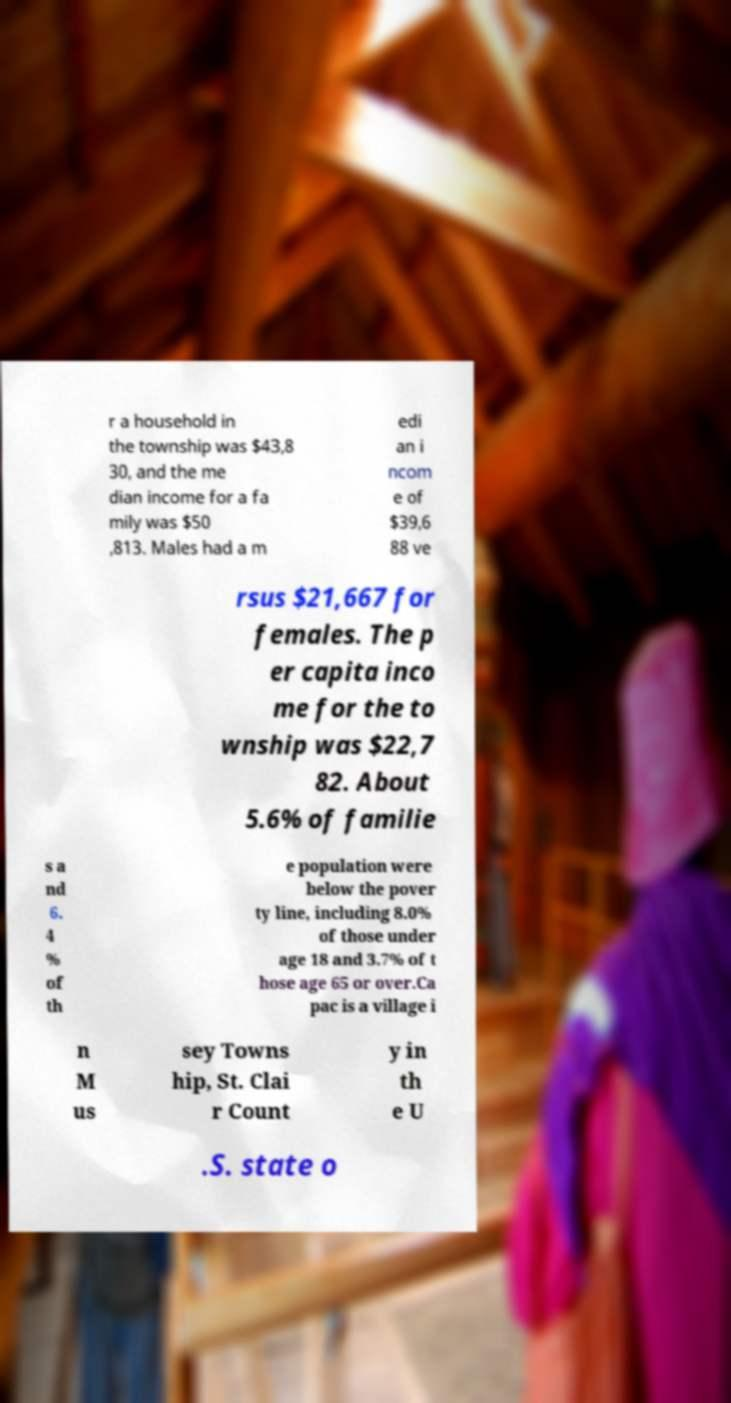Could you extract and type out the text from this image? r a household in the township was $43,8 30, and the me dian income for a fa mily was $50 ,813. Males had a m edi an i ncom e of $39,6 88 ve rsus $21,667 for females. The p er capita inco me for the to wnship was $22,7 82. About 5.6% of familie s a nd 6. 4 % of th e population were below the pover ty line, including 8.0% of those under age 18 and 3.7% of t hose age 65 or over.Ca pac is a village i n M us sey Towns hip, St. Clai r Count y in th e U .S. state o 